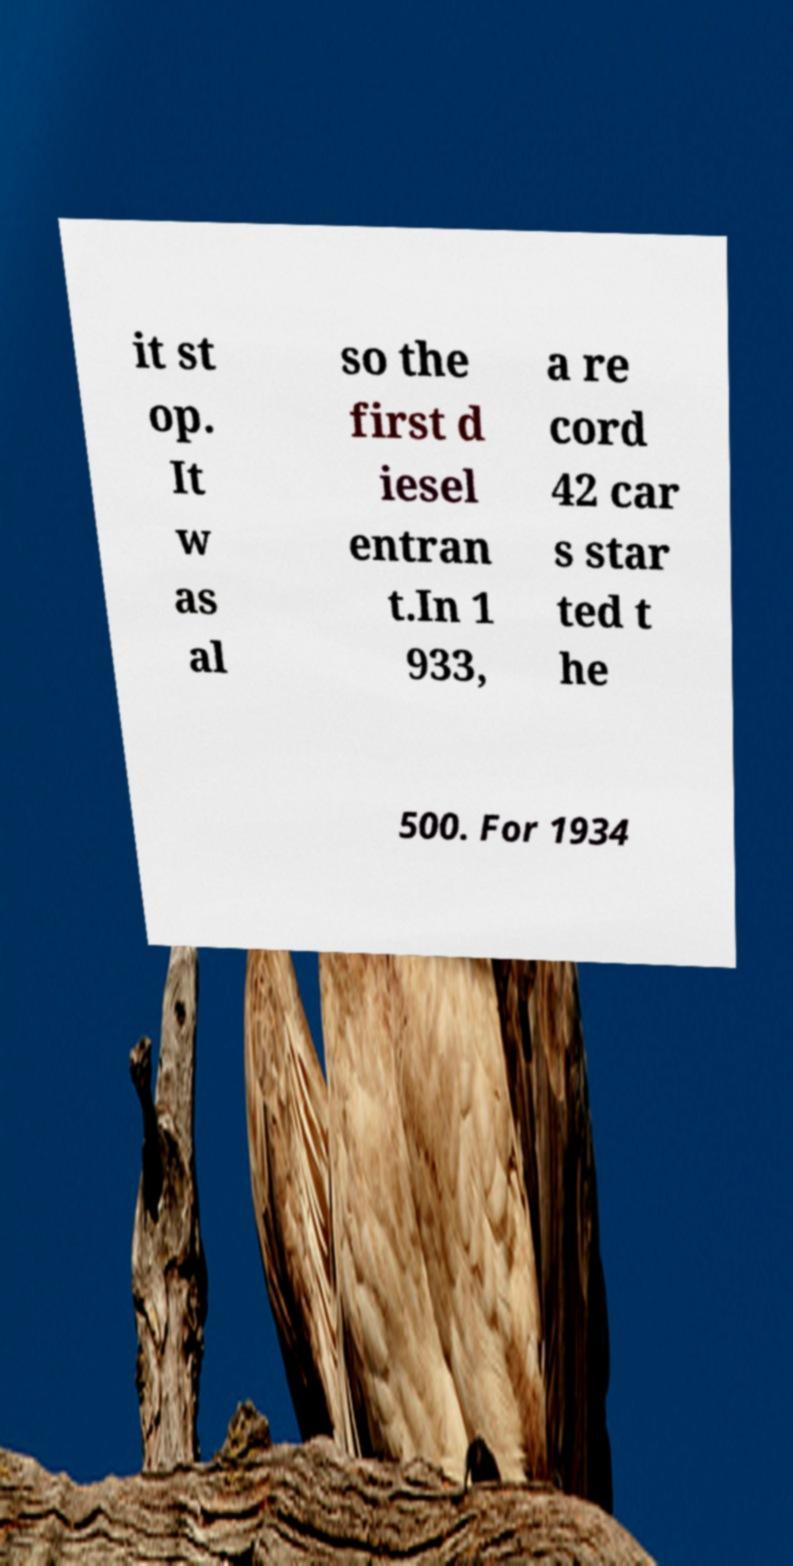Could you extract and type out the text from this image? it st op. It w as al so the first d iesel entran t.In 1 933, a re cord 42 car s star ted t he 500. For 1934 